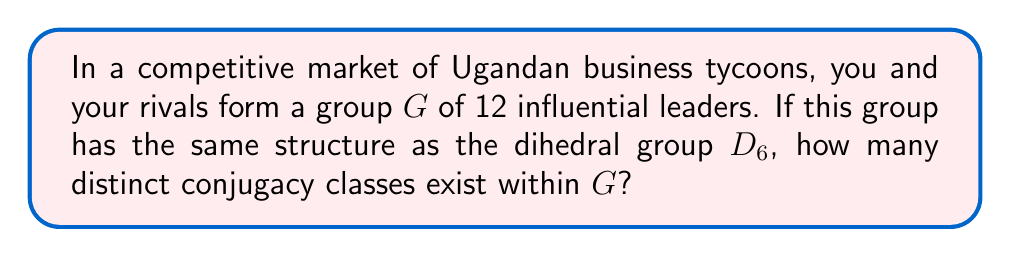Help me with this question. To solve this problem, we need to analyze the structure of the dihedral group $D_6$ and determine its conjugacy classes. Let's approach this step-by-step:

1) The dihedral group $D_6$ is the group of symmetries of a regular hexagon. It has order 12 and is generated by a rotation $r$ of order 6 and a reflection $s$ of order 2.

2) The elements of $D_6$ are: $\{e, r, r^2, r^3, r^4, r^5, s, sr, sr^2, sr^3, sr^4, sr^5\}$

3) To find the conjugacy classes, we need to consider how these elements conjugate with each other. Recall that elements $a$ and $b$ are conjugate if there exists an element $g$ in the group such that $gag^{-1} = b$.

4) Let's break down the conjugacy classes:
   
   a) $\{e\}$: The identity element is always in its own conjugacy class.
   
   b) $\{r^3\}$: The rotation by 180° (half-turn) is also in its own class.
   
   c) $\{r, r^5\}$: Rotations by 60° and 300° form a class.
   
   d) $\{r^2, r^4\}$: Rotations by 120° and 240° form a class.
   
   e) $\{s, sr^2, sr^4\}$: Reflections through axes passing through opposite vertices form a class.
   
   f) $\{sr, sr^3, sr^5\}$: Reflections through axes passing through the midpoints of opposite sides form a class.

5) Counting these classes, we find that there are 6 distinct conjugacy classes in $D_6$.

Therefore, in your group $G$ of 12 Ugandan business tycoons structured like $D_6$, there would be 6 distinct "influence classes" or conjugacy classes.
Answer: The number of conjugacy classes in the group $G$ is 6. 